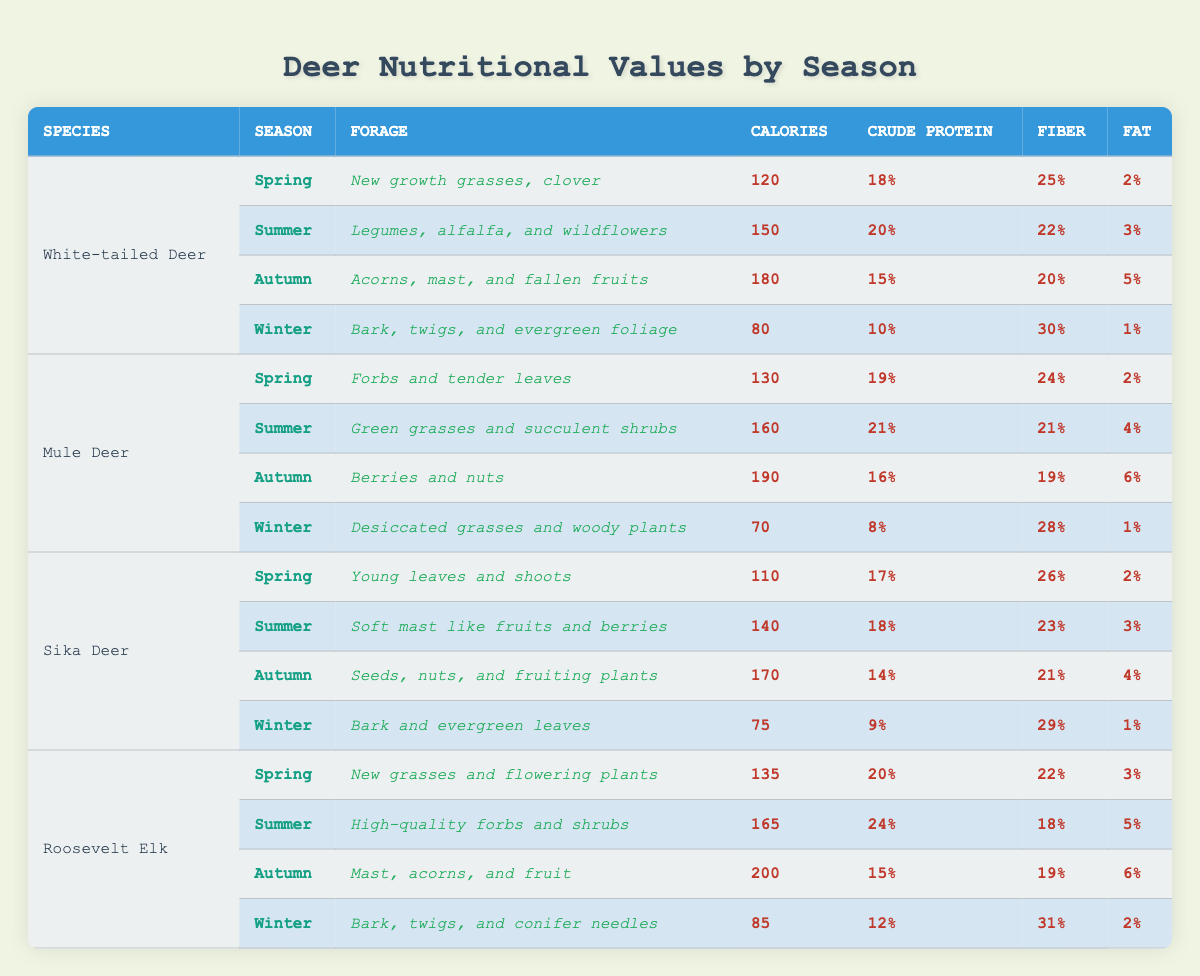What are the forage types for the White-tailed Deer in Spring? The table specifies that in Spring, the forage for White-tailed Deer consists of "New growth grasses, clover."
Answer: New growth grasses, clover Which deer species has the highest calorie intake during Autumn? The table shows that Roosevelt Elk has 200 calories while Mule Deer has 190 calories, White-tailed Deer has 180 calories, and Sika Deer has 170 calories in Autumn.
Answer: Roosevelt Elk What is the average crude protein percentage for Winter across all deer species? The crude protein percentages for Winter are 10% (White-tailed Deer), 8% (Mule Deer), 9% (Sika Deer), and 12% (Roosevelt Elk). Summing these gives 39%, and dividing by 4 gives an average of 9.75%.
Answer: 9.75% Does Mule Deer have the same forage in Winter as Sika Deer? The table indicates that Mule Deer has "Desiccated grasses and woody plants" for Winter, while Sika Deer has "Bark and evergreen leaves;" therefore, they do not have the same forage.
Answer: No In which season does Sika Deer have the lowest caloric intake and what is the value? Checking the seasons for Sika Deer, Winter has the lowest caloric intake of 75 calories compared to 110 (Spring), 140 (Summer), and 170 (Autumn).
Answer: Winter, 75 calories What are the differences in fat content between the diets of White-tailed Deer and Roosevelt Elk during Summer? White-tailed Deer has a fat content of 3% during Summer while Roosevelt Elk has 5%. The difference in fat content is 5% - 3% = 2%.
Answer: 2% Which species has the highest fiber content in Autumn? In Autumn, the fiber contents are 20% (White-tailed Deer), 19% (Mule Deer), 21% (Sika Deer), and 19% (Roosevelt Elk). Sika Deer has the highest at 21%.
Answer: Sika Deer What is the trend in calories for the White-tailed Deer from Spring to Winter? The calories for White-tailed Deer are 120 (Spring), 150 (Summer), 180 (Autumn), and 80 (Winter). This shows an increase from Spring to Autumn, followed by a significant decrease in Winter.
Answer: Increase then decrease Calculate the total crude protein percentage for each deer species across all seasons. For White-tailed Deer: 18% + 20% + 15% + 10% = 63%. Mule Deer: 19% + 21% + 16% + 8% = 64%. Sika Deer: 17% + 18% + 14% + 9% = 58%. Roosevelt Elk: 20% + 24% + 15% + 12% = 71%. The totals are different for each species.
Answer: Totals: White-tailed Deer 63%, Mule Deer 64%, Sika Deer 58%, Roosevelt Elk 71% Is the fiber content higher in Autumn for Mule Deer compared to Winter? The fiber content for Mule Deer in Autumn is 19% and in Winter is 28%; therefore, Autumn has lower fiber content than Winter.
Answer: No What percentage of total calories in Summer does the White-tailed Deer derive from its protein content? In Summer, the White-tailed Deer has 150 calories and 20% of those calories from protein is calculated as 150 * 0.20 = 30 calories from protein. Thus, the percentage is 30/150 * 100 = 20%.
Answer: 20% 